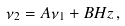Convert formula to latex. <formula><loc_0><loc_0><loc_500><loc_500>\nu _ { 2 } = A \nu _ { 1 } + B H z \, ,</formula> 